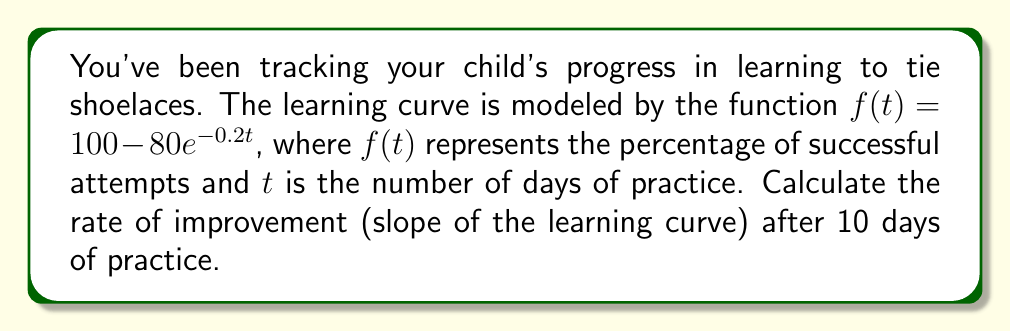Give your solution to this math problem. To find the rate of improvement (slope of the learning curve) after 10 days, we need to calculate the derivative of the function $f(t)$ and evaluate it at $t=10$.

Step 1: Find the derivative of $f(t)$
$f(t) = 100 - 80e^{-0.2t}$
$f'(t) = -80 \cdot (-0.2e^{-0.2t})$ (using the chain rule)
$f'(t) = 16e^{-0.2t}$

Step 2: Evaluate $f'(t)$ at $t=10$
$f'(10) = 16e^{-0.2(10)}$
$f'(10) = 16e^{-2}$
$f'(10) \approx 16 \cdot 0.1353 \approx 2.1648$

Step 3: Interpret the result
The rate of improvement after 10 days is approximately 2.1648 percentage points per day. This represents the instantaneous rate of change in the child's success rate at tying shoelaces after 10 days of practice.
Answer: $2.1648$ percentage points per day 